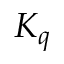Convert formula to latex. <formula><loc_0><loc_0><loc_500><loc_500>K _ { q }</formula> 